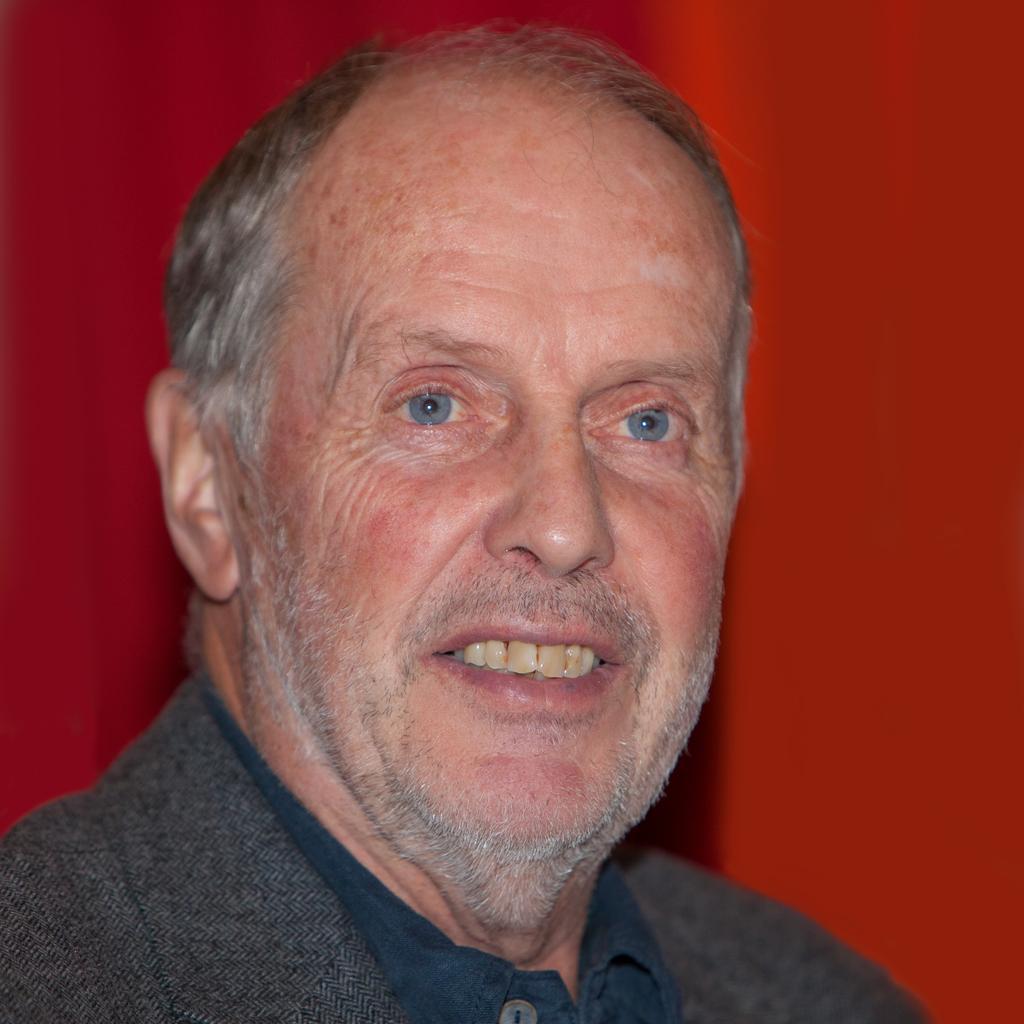In one or two sentences, can you explain what this image depicts? In this image, we can see a person wearing clothes on the red background. 